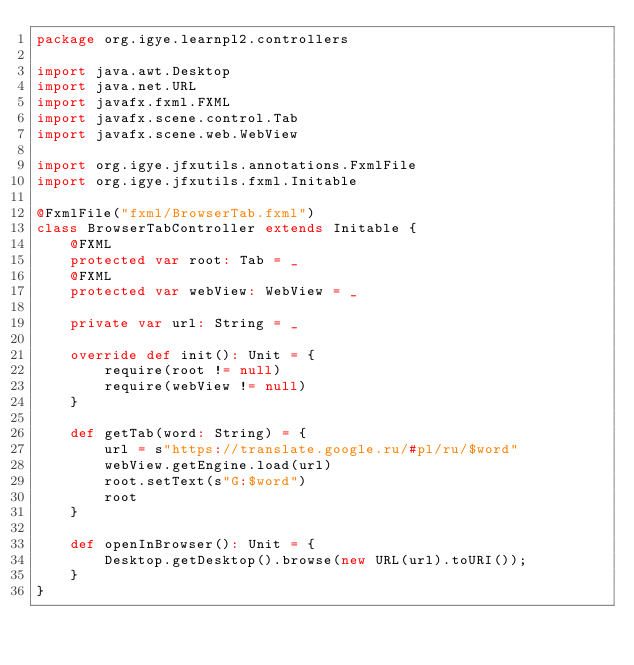Convert code to text. <code><loc_0><loc_0><loc_500><loc_500><_Scala_>package org.igye.learnpl2.controllers

import java.awt.Desktop
import java.net.URL
import javafx.fxml.FXML
import javafx.scene.control.Tab
import javafx.scene.web.WebView

import org.igye.jfxutils.annotations.FxmlFile
import org.igye.jfxutils.fxml.Initable

@FxmlFile("fxml/BrowserTab.fxml")
class BrowserTabController extends Initable {
    @FXML
    protected var root: Tab = _
    @FXML
    protected var webView: WebView = _

    private var url: String = _

    override def init(): Unit = {
        require(root != null)
        require(webView != null)
    }

    def getTab(word: String) = {
        url = s"https://translate.google.ru/#pl/ru/$word"
        webView.getEngine.load(url)
        root.setText(s"G:$word")
        root
    }

    def openInBrowser(): Unit = {
        Desktop.getDesktop().browse(new URL(url).toURI());
    }
}
</code> 